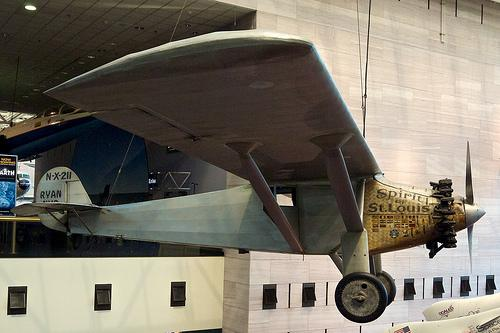Mention what the image may signify in a historic context. Commemorating the legendary aircraft, the image encapsulates the timeless "Spirit of St Louis" with all its components in a serene museum ambiance. Write a straightforward description of the primary object in the image. An airplane model named "Spirit of St Louis" is hanging from the ceiling, with visible wheels, propeller, and decals. Describe the components of the "Spirit of St Louis" airplane in the image. The "Spirit of St Louis" airplane showcases its two visible wheels, round tail fin, cutting-edge propeller, striking wings, and iconic decals. Create a vivid mental picture of the image. Envision a well-lit setting exhibiting an awe-inspiring, hanging airplane - the "Spirit of St Louis," complete with wheels, propeller, and a name adorned on its exterior. Provide a brief narrative about the scene depicted in the image. In the calmness of a museum, an impressive aircraft called "Spirit of St Louis" hangs gracefully from cables, showcasing its wheels, propeller, and decals. Highlight the visual emphasis of the airplane displayed in the image. Proudly suspended, the "Spirit of St Louis" captivates attention with its prominent wings, propeller, wheels, and bold "Ryan" and "St Louis" decals. Portray the image focusing on the airplane's suspension system. Held up by sturdy cables, the "Spirit of St Louis" airplane floats effortlessly, highlighting its wheels, propeller, and decals amid a museum backdrop. Describe the image focusing on its colors and shapes. A large, well-lit room displaying a hanging airplane with a blue underbelly, a round tail fin, and various distinct shapes of wings, wheels, and propeller. Summarize the main elements of the image in one sentence. The image features a hanging airplane model with visible wheels, a propeller, and decals, set in a museum environment. Provide an artistic expression of the image. The "Spirit of St Louis" hovers gracefully, its wheels and propeller glistening, while its historic name takes center stage in a monumental display. 